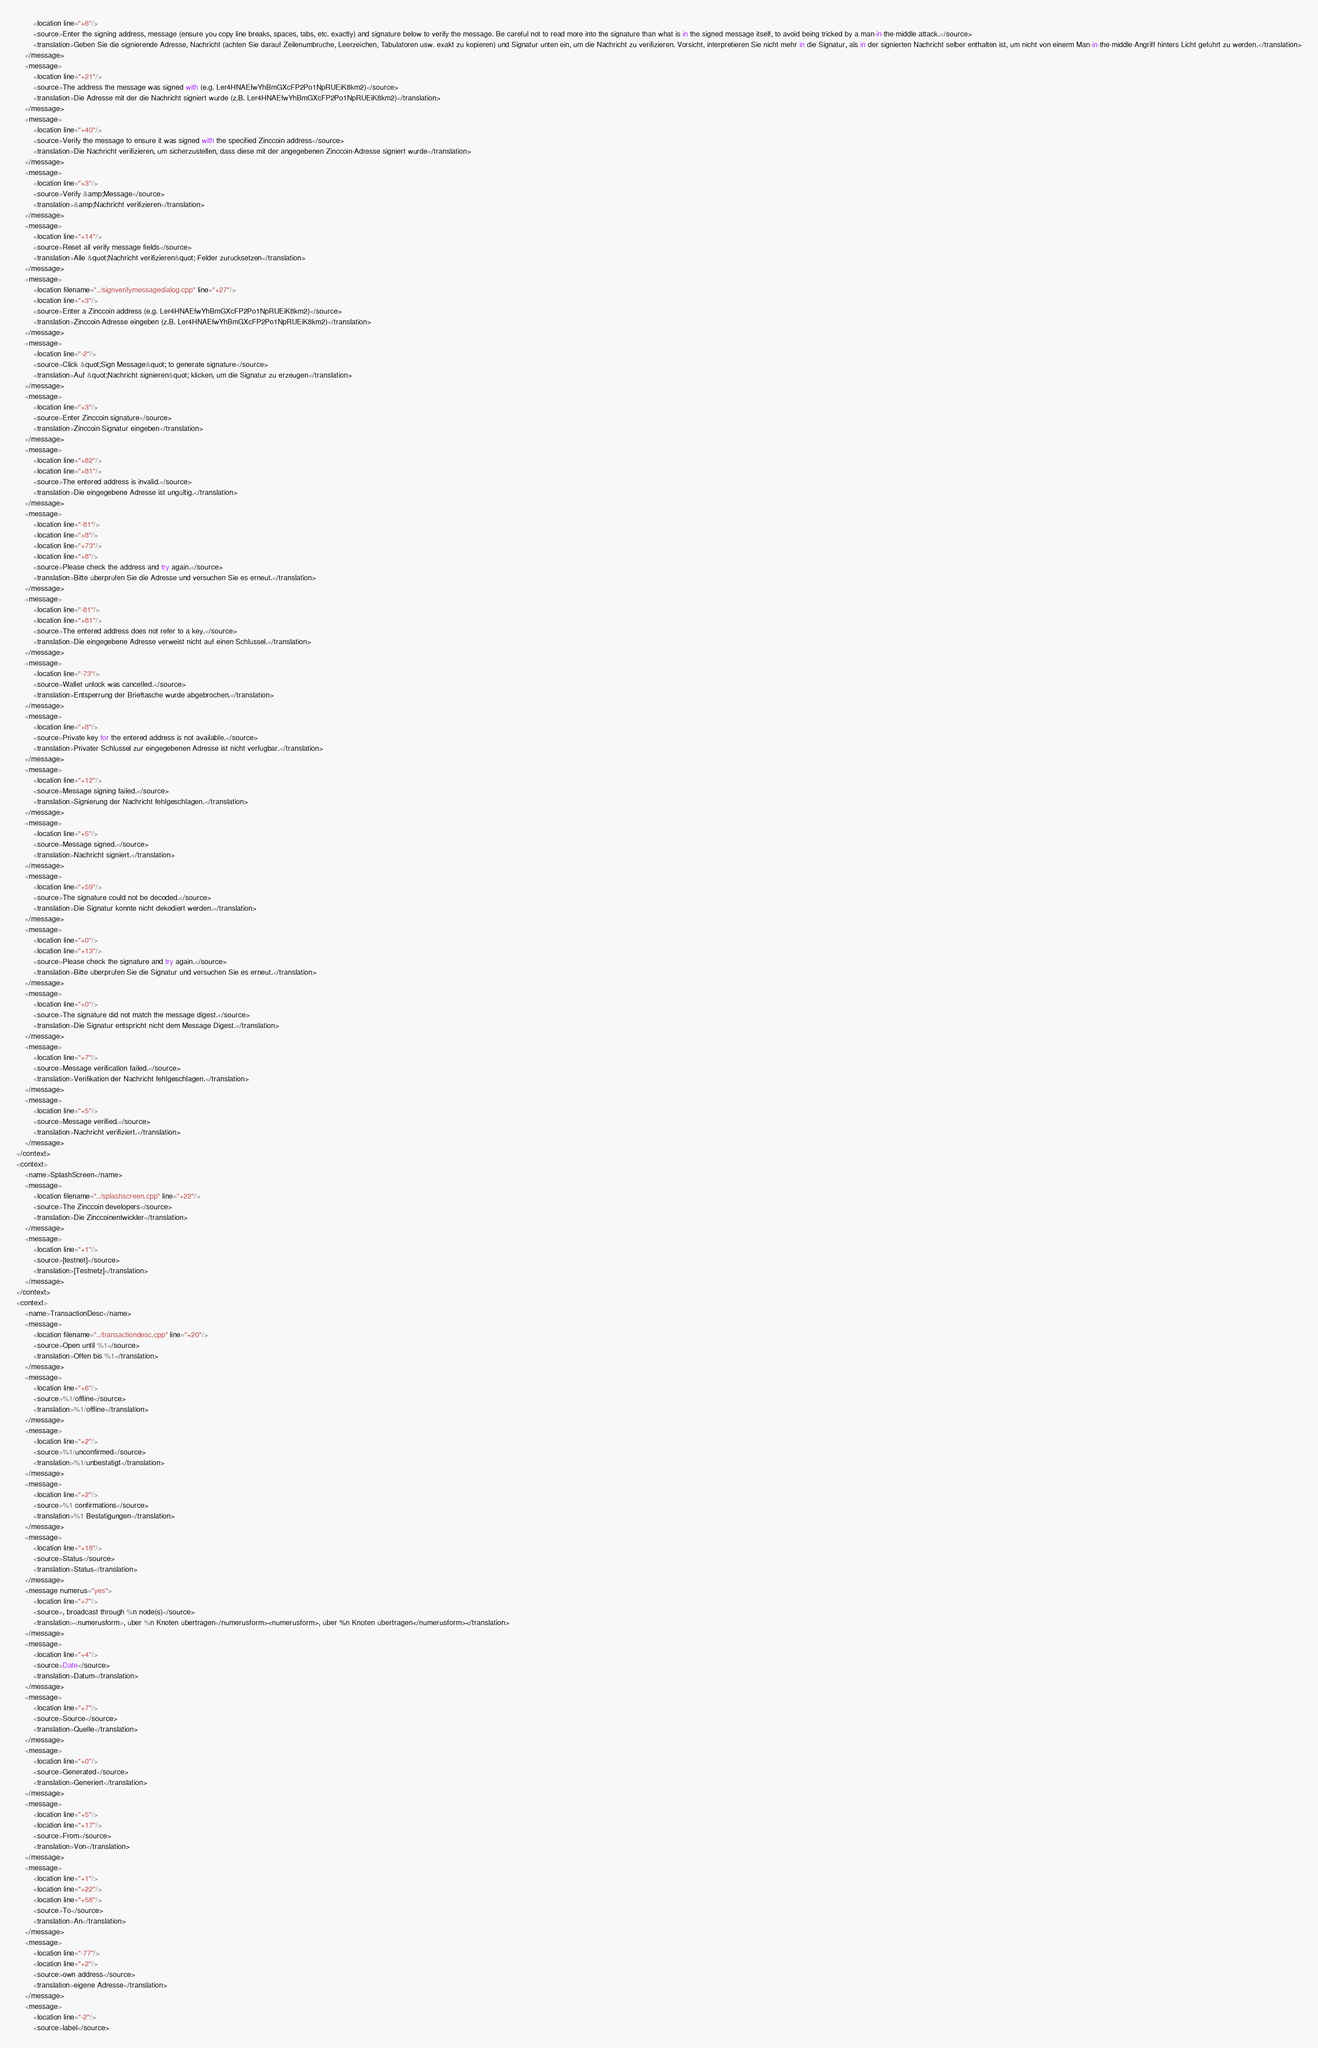Convert code to text. <code><loc_0><loc_0><loc_500><loc_500><_TypeScript_>        <location line="+6"/>
        <source>Enter the signing address, message (ensure you copy line breaks, spaces, tabs, etc. exactly) and signature below to verify the message. Be careful not to read more into the signature than what is in the signed message itself, to avoid being tricked by a man-in-the-middle attack.</source>
        <translation>Geben Sie die signierende Adresse, Nachricht (achten Sie darauf Zeilenumbrüche, Leerzeichen, Tabulatoren usw. exakt zu kopieren) und Signatur unten ein, um die Nachricht zu verifizieren. Vorsicht, interpretieren Sie nicht mehr in die Signatur, als in der signierten Nachricht selber enthalten ist, um nicht von einerm Man-in-the-middle-Angriff hinters Licht geführt zu werden.</translation>
    </message>
    <message>
        <location line="+21"/>
        <source>The address the message was signed with (e.g. Ler4HNAEfwYhBmGXcFP2Po1NpRUEiK8km2)</source>
        <translation>Die Adresse mit der die Nachricht signiert wurde (z.B. Ler4HNAEfwYhBmGXcFP2Po1NpRUEiK8km2)</translation>
    </message>
    <message>
        <location line="+40"/>
        <source>Verify the message to ensure it was signed with the specified Zinccoin address</source>
        <translation>Die Nachricht verifizieren, um sicherzustellen, dass diese mit der angegebenen Zinccoin-Adresse signiert wurde</translation>
    </message>
    <message>
        <location line="+3"/>
        <source>Verify &amp;Message</source>
        <translation>&amp;Nachricht verifizieren</translation>
    </message>
    <message>
        <location line="+14"/>
        <source>Reset all verify message fields</source>
        <translation>Alle &quot;Nachricht verifizieren&quot;-Felder zurücksetzen</translation>
    </message>
    <message>
        <location filename="../signverifymessagedialog.cpp" line="+27"/>
        <location line="+3"/>
        <source>Enter a Zinccoin address (e.g. Ler4HNAEfwYhBmGXcFP2Po1NpRUEiK8km2)</source>
        <translation>Zinccoin-Adresse eingeben (z.B. Ler4HNAEfwYhBmGXcFP2Po1NpRUEiK8km2)</translation>
    </message>
    <message>
        <location line="-2"/>
        <source>Click &quot;Sign Message&quot; to generate signature</source>
        <translation>Auf &quot;Nachricht signieren&quot; klicken, um die Signatur zu erzeugen</translation>
    </message>
    <message>
        <location line="+3"/>
        <source>Enter Zinccoin signature</source>
        <translation>Zinccoin-Signatur eingeben</translation>
    </message>
    <message>
        <location line="+82"/>
        <location line="+81"/>
        <source>The entered address is invalid.</source>
        <translation>Die eingegebene Adresse ist ungültig.</translation>
    </message>
    <message>
        <location line="-81"/>
        <location line="+8"/>
        <location line="+73"/>
        <location line="+8"/>
        <source>Please check the address and try again.</source>
        <translation>Bitte überprüfen Sie die Adresse und versuchen Sie es erneut.</translation>
    </message>
    <message>
        <location line="-81"/>
        <location line="+81"/>
        <source>The entered address does not refer to a key.</source>
        <translation>Die eingegebene Adresse verweist nicht auf einen Schlüssel.</translation>
    </message>
    <message>
        <location line="-73"/>
        <source>Wallet unlock was cancelled.</source>
        <translation>Entsperrung der Brieftasche wurde abgebrochen.</translation>
    </message>
    <message>
        <location line="+8"/>
        <source>Private key for the entered address is not available.</source>
        <translation>Privater Schlüssel zur eingegebenen Adresse ist nicht verfügbar.</translation>
    </message>
    <message>
        <location line="+12"/>
        <source>Message signing failed.</source>
        <translation>Signierung der Nachricht fehlgeschlagen.</translation>
    </message>
    <message>
        <location line="+5"/>
        <source>Message signed.</source>
        <translation>Nachricht signiert.</translation>
    </message>
    <message>
        <location line="+59"/>
        <source>The signature could not be decoded.</source>
        <translation>Die Signatur konnte nicht dekodiert werden.</translation>
    </message>
    <message>
        <location line="+0"/>
        <location line="+13"/>
        <source>Please check the signature and try again.</source>
        <translation>Bitte überprüfen Sie die Signatur und versuchen Sie es erneut.</translation>
    </message>
    <message>
        <location line="+0"/>
        <source>The signature did not match the message digest.</source>
        <translation>Die Signatur entspricht nicht dem Message Digest.</translation>
    </message>
    <message>
        <location line="+7"/>
        <source>Message verification failed.</source>
        <translation>Verifikation der Nachricht fehlgeschlagen.</translation>
    </message>
    <message>
        <location line="+5"/>
        <source>Message verified.</source>
        <translation>Nachricht verifiziert.</translation>
    </message>
</context>
<context>
    <name>SplashScreen</name>
    <message>
        <location filename="../splashscreen.cpp" line="+22"/>
        <source>The Zinccoin developers</source>
        <translation>Die Zinccoinentwickler</translation>
    </message>
    <message>
        <location line="+1"/>
        <source>[testnet]</source>
        <translation>[Testnetz]</translation>
    </message>
</context>
<context>
    <name>TransactionDesc</name>
    <message>
        <location filename="../transactiondesc.cpp" line="+20"/>
        <source>Open until %1</source>
        <translation>Offen bis %1</translation>
    </message>
    <message>
        <location line="+6"/>
        <source>%1/offline</source>
        <translation>%1/offline</translation>
    </message>
    <message>
        <location line="+2"/>
        <source>%1/unconfirmed</source>
        <translation>%1/unbestätigt</translation>
    </message>
    <message>
        <location line="+2"/>
        <source>%1 confirmations</source>
        <translation>%1 Bestätigungen</translation>
    </message>
    <message>
        <location line="+18"/>
        <source>Status</source>
        <translation>Status</translation>
    </message>
    <message numerus="yes">
        <location line="+7"/>
        <source>, broadcast through %n node(s)</source>
        <translation><numerusform>, über %n Knoten übertragen</numerusform><numerusform>, über %n Knoten übertragen</numerusform></translation>
    </message>
    <message>
        <location line="+4"/>
        <source>Date</source>
        <translation>Datum</translation>
    </message>
    <message>
        <location line="+7"/>
        <source>Source</source>
        <translation>Quelle</translation>
    </message>
    <message>
        <location line="+0"/>
        <source>Generated</source>
        <translation>Generiert</translation>
    </message>
    <message>
        <location line="+5"/>
        <location line="+17"/>
        <source>From</source>
        <translation>Von</translation>
    </message>
    <message>
        <location line="+1"/>
        <location line="+22"/>
        <location line="+58"/>
        <source>To</source>
        <translation>An</translation>
    </message>
    <message>
        <location line="-77"/>
        <location line="+2"/>
        <source>own address</source>
        <translation>eigene Adresse</translation>
    </message>
    <message>
        <location line="-2"/>
        <source>label</source></code> 